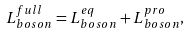Convert formula to latex. <formula><loc_0><loc_0><loc_500><loc_500>L _ { b o s o n } ^ { f u l l } = L _ { b o s o n } ^ { e q } + L _ { b o s o n } ^ { p r o } ,</formula> 